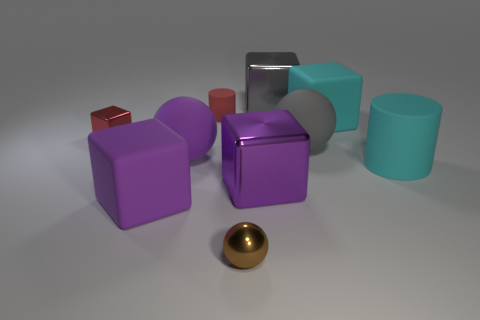Can you tell me what the largest object in the image is and its color? Certainly! The largest object appears to be the cylinder on the right side of the image, which has a cool, mint green color. 